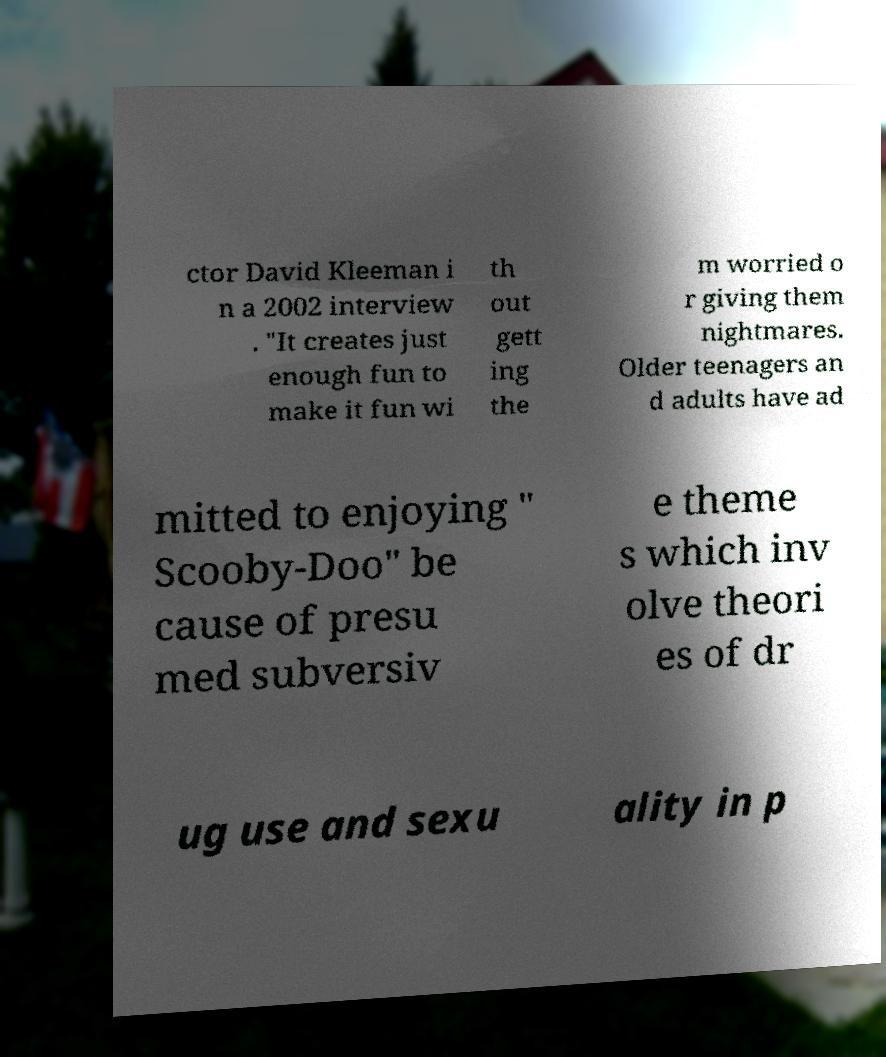For documentation purposes, I need the text within this image transcribed. Could you provide that? ctor David Kleeman i n a 2002 interview . "It creates just enough fun to make it fun wi th out gett ing the m worried o r giving them nightmares. Older teenagers an d adults have ad mitted to enjoying " Scooby-Doo" be cause of presu med subversiv e theme s which inv olve theori es of dr ug use and sexu ality in p 